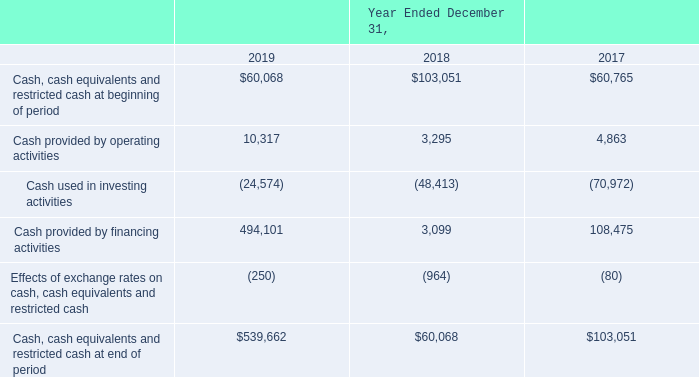Cash Flows
The following table summarizes our cash flows for the years ended December 31, 2019, 2018 and 2017 (in thousands):
At December 31, 2019, $6.7 million of the $539.7 million of cash, cash equivalents and restricted cash was held by foreign subsidiaries. Our intention is to indefinitely reinvest foreign earnings in our foreign subsidiaries. If these earnings were used to fund domestic operations, they would be subject to additional income taxes upon repatriation.
How much cash, cash equivalents and restricted cash was held by foreign subsidiaries at December 31, 2019? $6.7 million of the $539.7 million of cash, cash equivalents and restricted cash. Where is foreign earnings reinvested? In our foreign subsidiaries. What would happen if earnings were used to fund domestic operations? Subject to additional income taxes upon repatriation. What is the change in Cash, cash equivalents and restricted cash at beginning of period from December 31, 2019 to December 31, 2018?
Answer scale should be: thousand. 60,068-103,051
Answer: -42983. What is the change in Cash provided by operating activities from December 31, 2019 to December 31, 2018?
Answer scale should be: thousand. 10,317-3,295
Answer: 7022. What is the change in Cash used in investing activities from December 31, 2019 to December 31, 2018?
Answer scale should be: thousand. 24,574-48,413
Answer: -23839. 